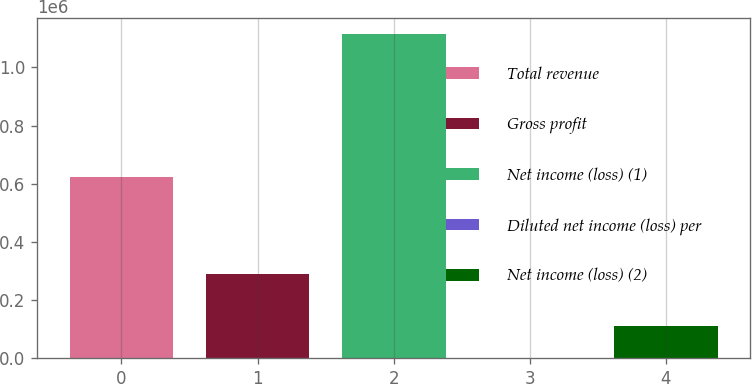Convert chart to OTSL. <chart><loc_0><loc_0><loc_500><loc_500><bar_chart><fcel>Total revenue<fcel>Gross profit<fcel>Net income (loss) (1)<fcel>Diluted net income (loss) per<fcel>Net income (loss) (2)<nl><fcel>622118<fcel>290631<fcel>1.1139e+06<fcel>4.11<fcel>111394<nl></chart> 